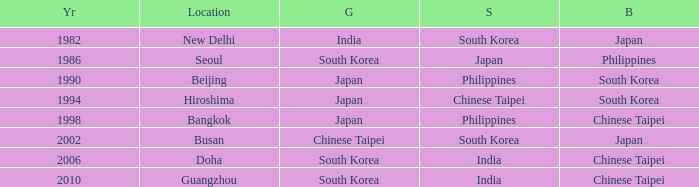How many years has Japan won silver? 1986.0. 